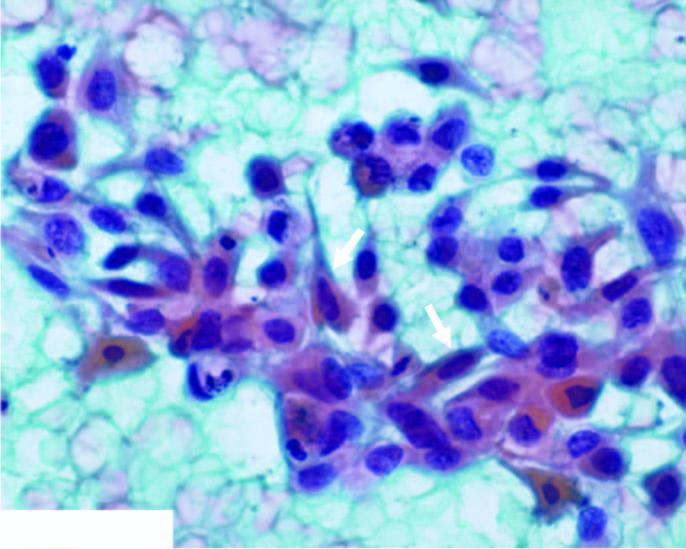what does the background show?
Answer the question using a single word or phrase. Abundant haemorrhage and some necrotic debris 